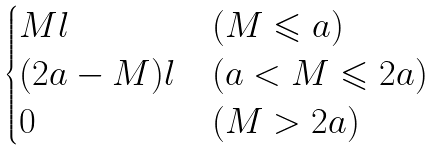Convert formula to latex. <formula><loc_0><loc_0><loc_500><loc_500>\begin{cases} M l & ( M \leqslant a ) \\ ( 2 a - M ) l & ( a < M \leqslant 2 a ) \\ 0 & ( M > 2 a ) \end{cases}</formula> 